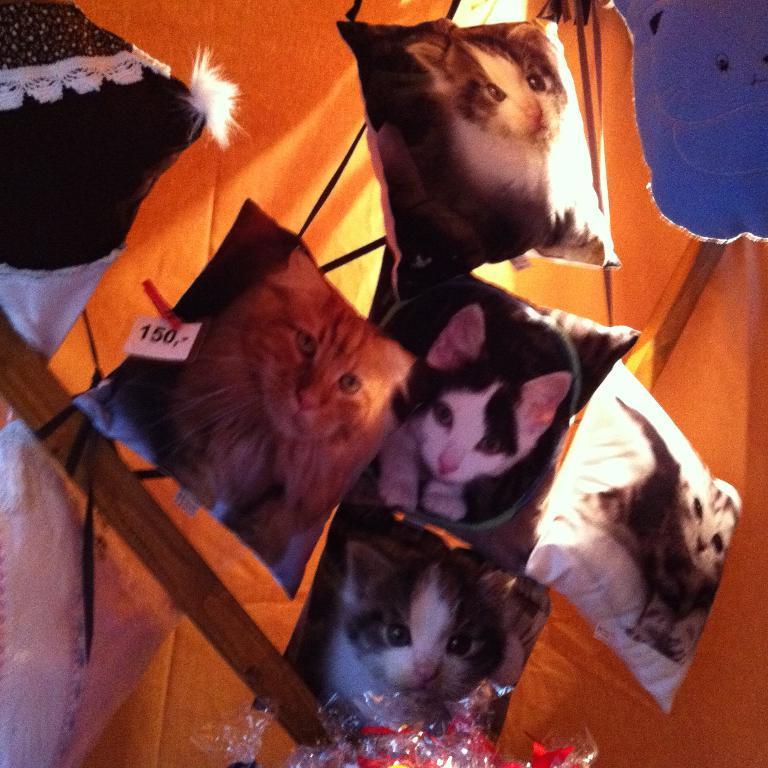Please provide a concise description of this image. In this image we can see pillows upon which we can see cat pictures. Here we can see wooden stick and tent in the background. 